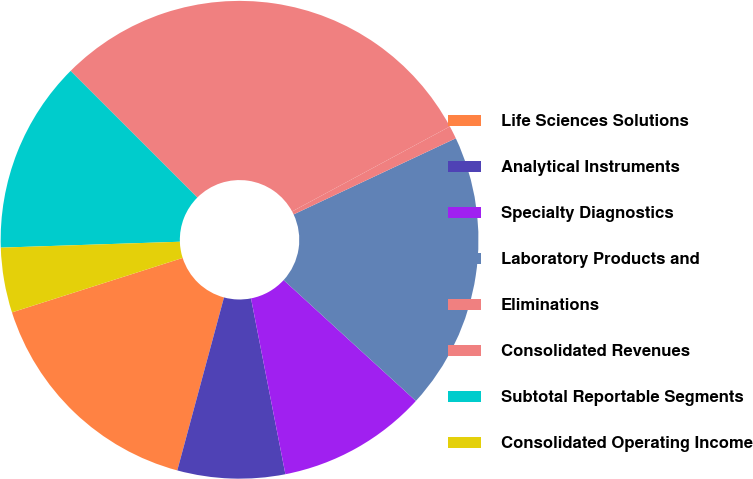Convert chart to OTSL. <chart><loc_0><loc_0><loc_500><loc_500><pie_chart><fcel>Life Sciences Solutions<fcel>Analytical Instruments<fcel>Specialty Diagnostics<fcel>Laboratory Products and<fcel>Eliminations<fcel>Consolidated Revenues<fcel>Subtotal Reportable Segments<fcel>Consolidated Operating Income<nl><fcel>15.89%<fcel>7.27%<fcel>10.14%<fcel>18.77%<fcel>0.88%<fcel>29.64%<fcel>13.02%<fcel>4.39%<nl></chart> 